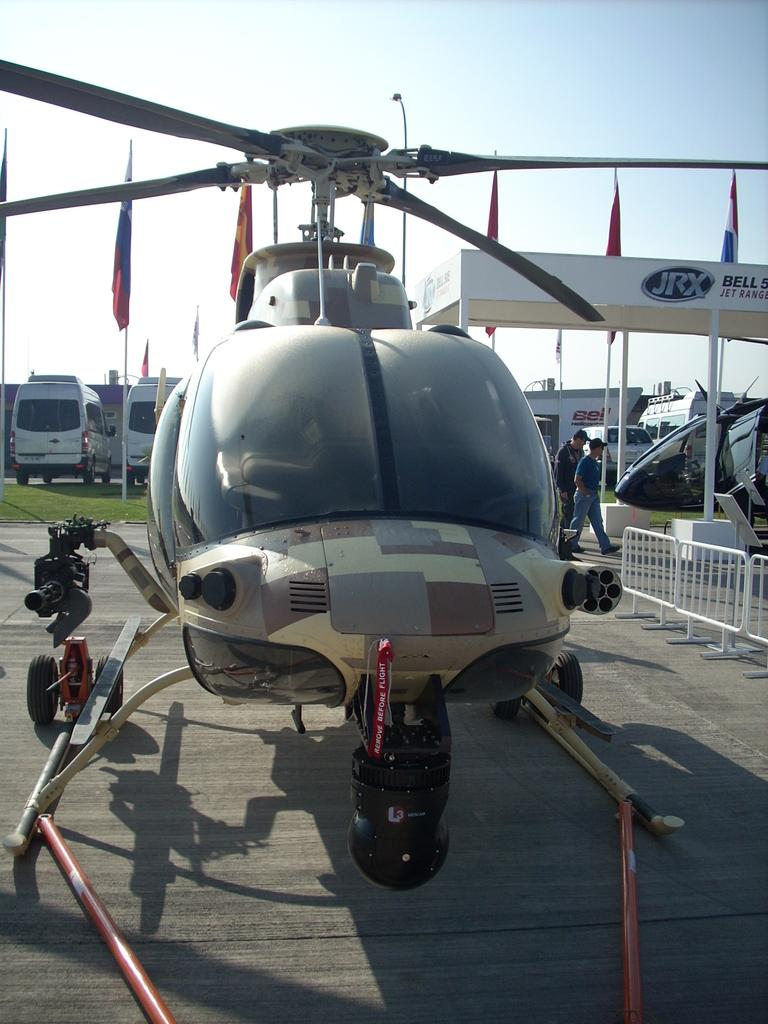What is the main subject of the image? The main subject of the image is a helicopter. What can be seen on the left side of the image? There are vans on the left side of the image. What is visible at the top of the image? The sky is visible at the top of the image. What are the two persons at the bottom of the image doing? The two persons at the bottom of the image are walking. What type of harmony is being played by the helicopter in the image? There is no indication of music or harmony in the image; it features a helicopter and other subjects. Can you tell me the relationship between the two persons walking and the helicopter in the image? There is no information about the relationship between the persons and the helicopter in the image. 